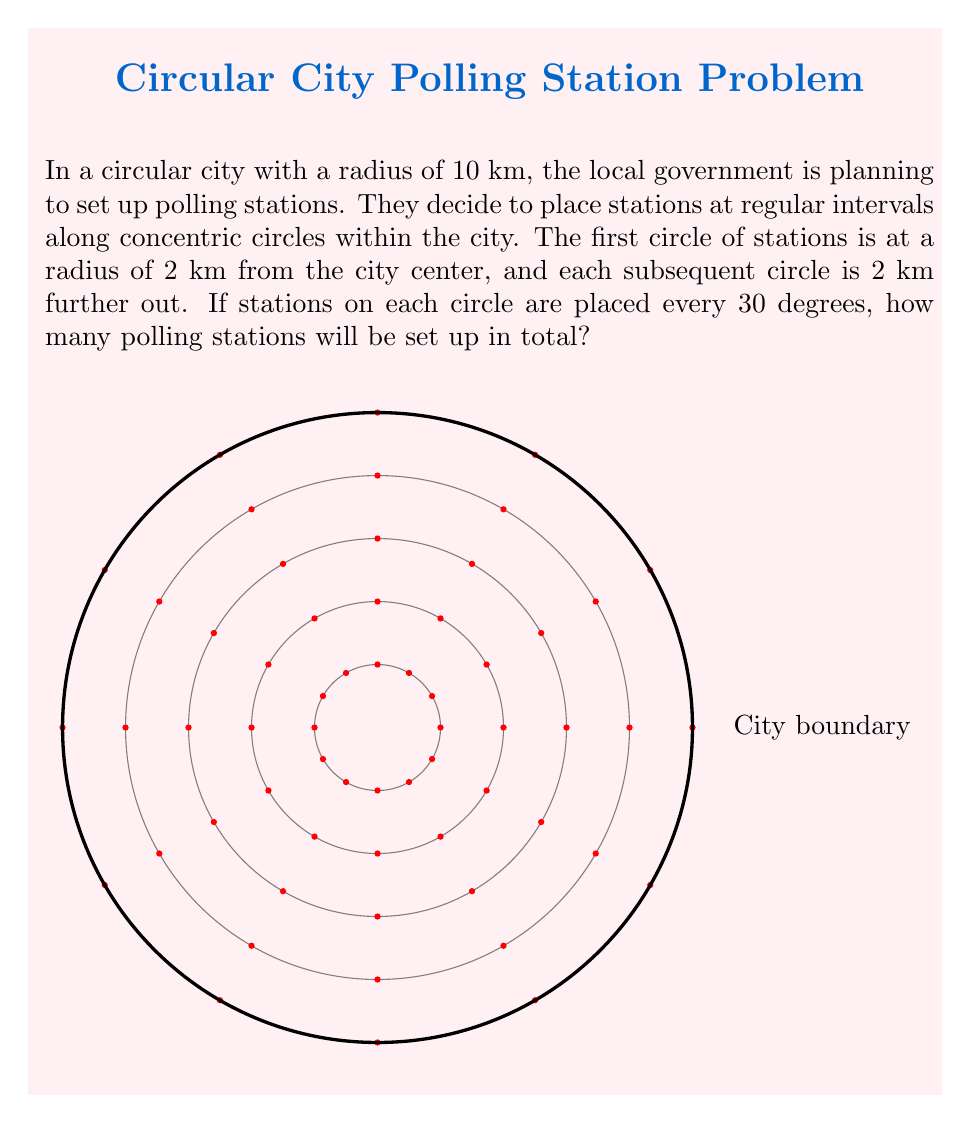Provide a solution to this math problem. Let's approach this step-by-step:

1) We need to determine how many circles of polling stations there will be:
   - The city radius is 10 km
   - Stations start at 2 km and are placed every 2 km
   - So, the circles will be at 2, 4, 6, 8, and 10 km
   - That's 5 circles in total

2) Now, let's calculate how many stations are on each circle:
   - Stations are placed every 30 degrees
   - There are 360 degrees in a circle
   - So, the number of stations per circle = 360° ÷ 30° = 12

3) To get the total number of stations, we multiply the number of circles by the number of stations per circle:
   $$ \text{Total stations} = 5 \text{ circles} \times 12 \text{ stations per circle} = 60 \text{ stations} $$

This solution efficiently distributes polling stations throughout the city, ensuring equal angular spacing and increasing density towards the center where population is likely to be higher.
Answer: 60 polling stations 